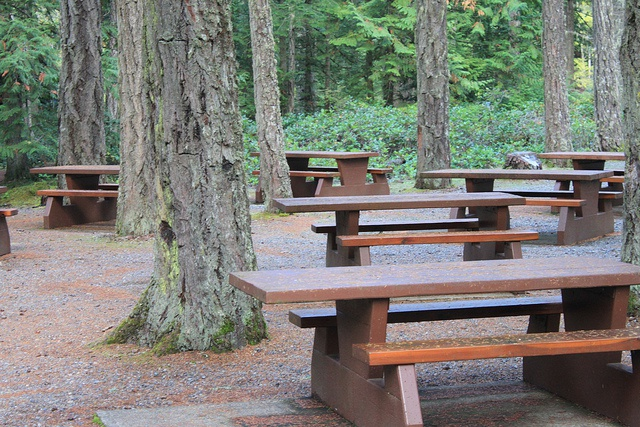Describe the objects in this image and their specific colors. I can see bench in black, brown, darkgray, and gray tones, bench in black, gray, and darkgray tones, bench in black, gray, maroon, and lavender tones, bench in black, gray, maroon, and darkgray tones, and bench in black, gray, and darkgray tones in this image. 